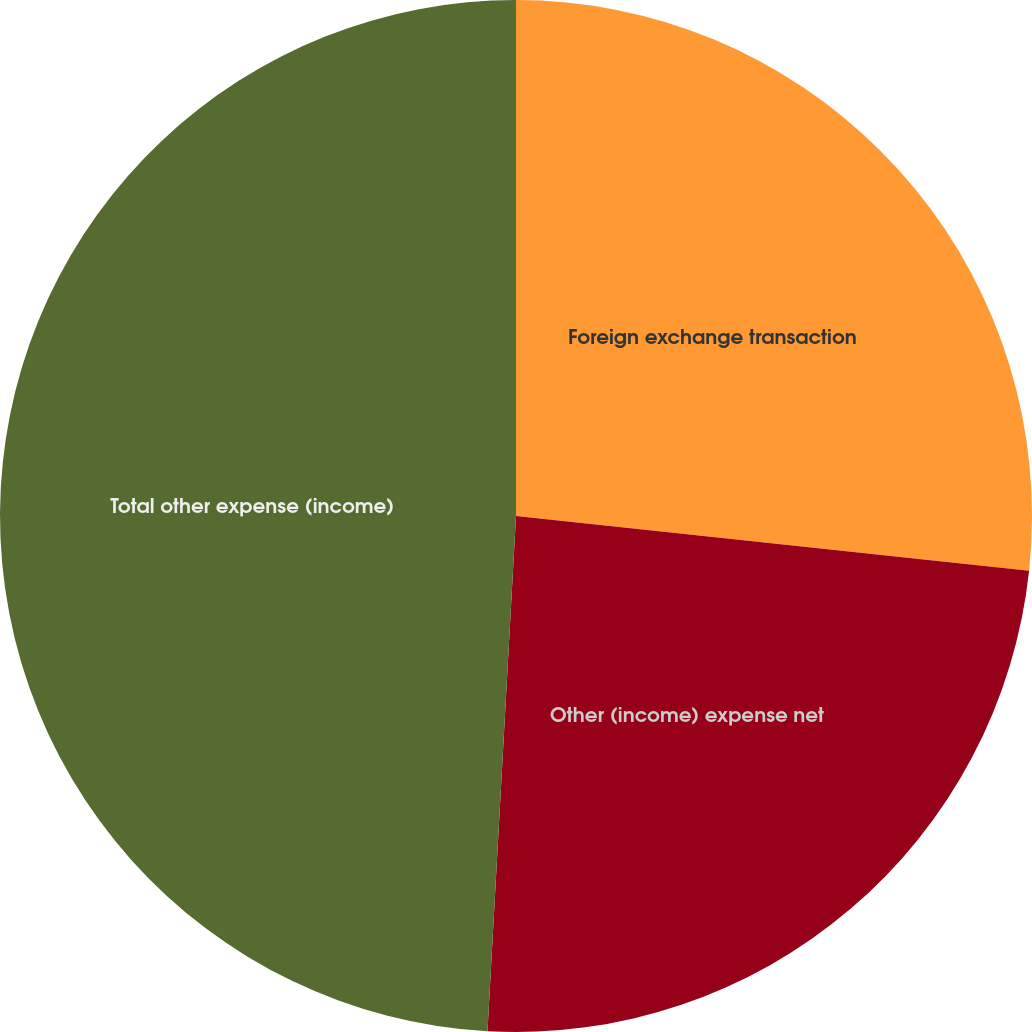Convert chart. <chart><loc_0><loc_0><loc_500><loc_500><pie_chart><fcel>Foreign exchange transaction<fcel>Other (income) expense net<fcel>Total other expense (income)<nl><fcel>26.69%<fcel>24.19%<fcel>49.12%<nl></chart> 